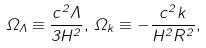Convert formula to latex. <formula><loc_0><loc_0><loc_500><loc_500>\Omega _ { \Lambda } \equiv \frac { c ^ { 2 } \Lambda } { 3 H ^ { 2 } } , \, \Omega _ { k } \equiv - \frac { c ^ { 2 } k } { H ^ { 2 } R ^ { 2 } } ,</formula> 